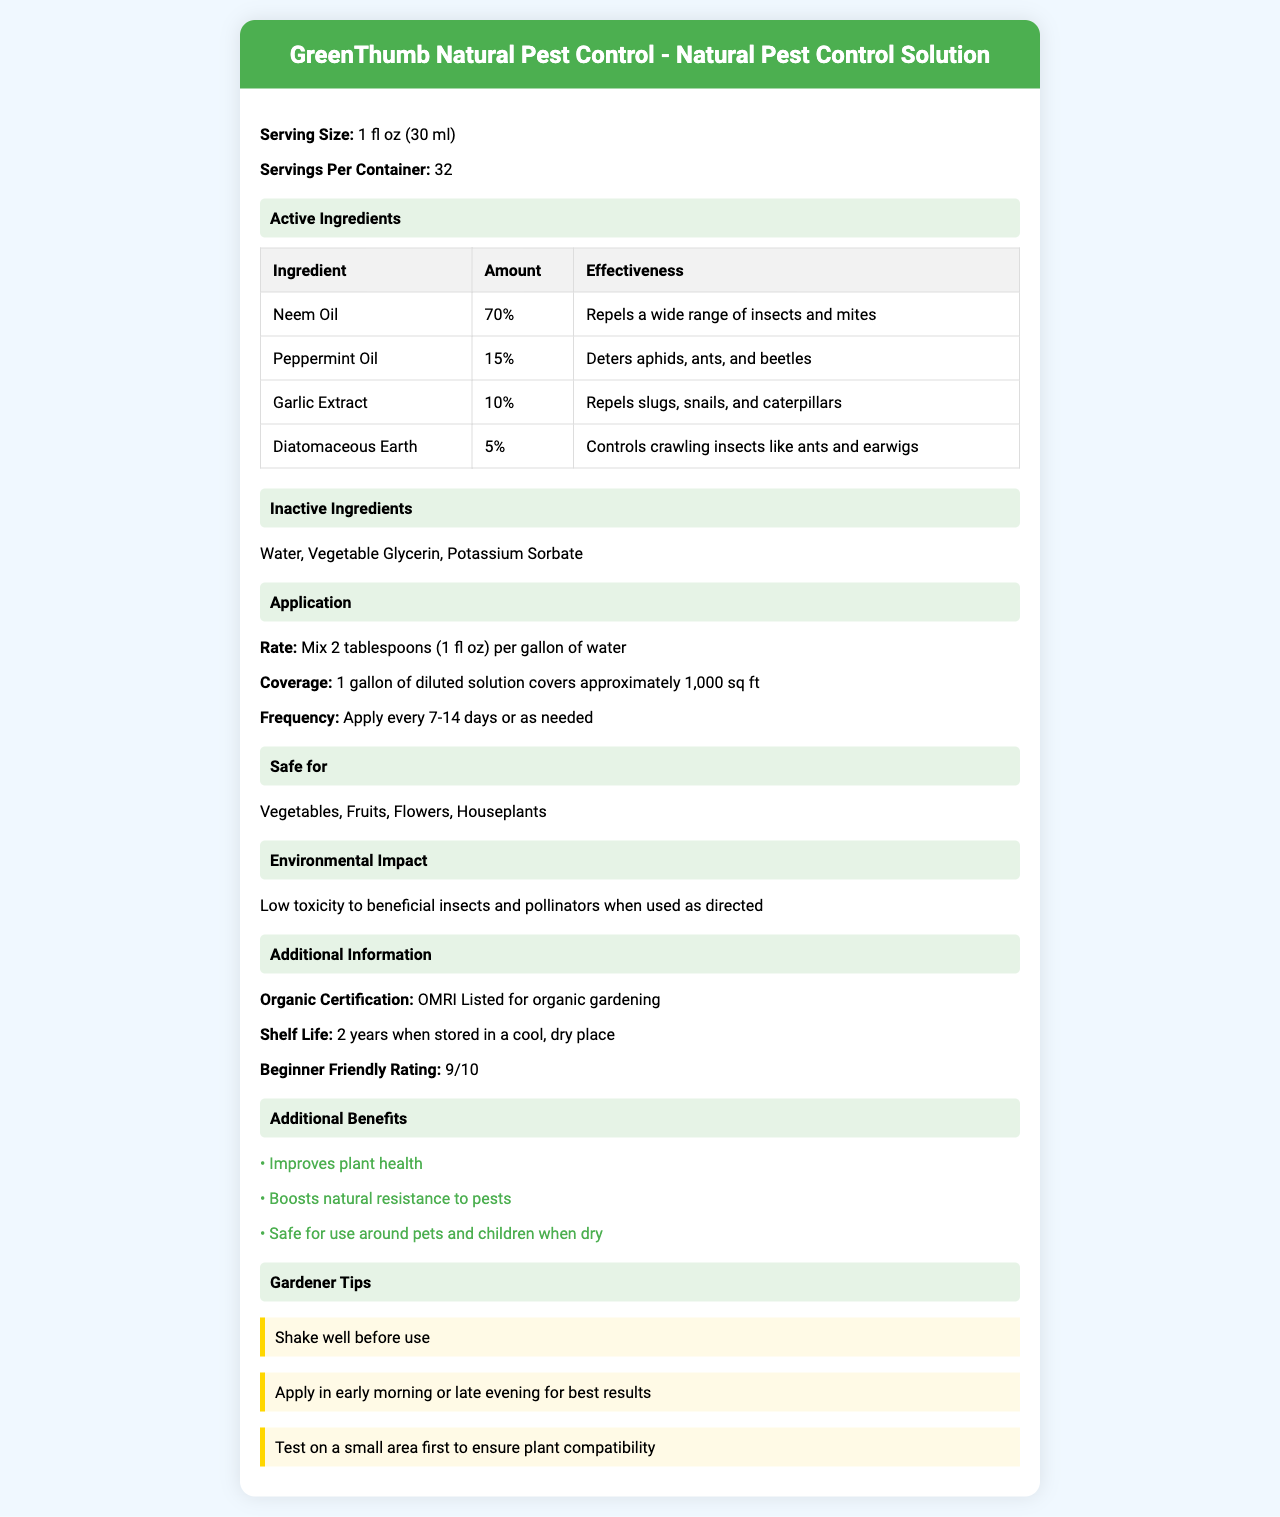what is the product name? The document specifies that the product name is "GreenThumb Natural Pest Control".
Answer: GreenThumb Natural Pest Control what is the serving size for the product? The serving size is mentioned as 1 fl oz (30 ml).
Answer: 1 fl oz (30 ml) how many servings per container are there? The document states that there are 32 servings per container.
Answer: 32 what percentage of the product is neem oil? Neem oil is listed as making up 70% of the product's active ingredients.
Answer: 70% what insects does peppermint oil deter? According to the document, peppermint oil deters aphids, ants, and beetles.
Answer: Aphids, ants, and beetles what is the application rate for the product? The application rate is specified as mixing 2 tablespoons (1 fl oz) per gallon of water.
Answer: Mix 2 tablespoons (1 fl oz) per gallon of water how often should the product be applied? The frequency of use is mentioned as applying every 7-14 days or as needed.
Answer: Every 7-14 days or as needed what is the organic certification of the product? The product is OMRI Listed for organic gardening.
Answer: OMRI Listed for organic gardening what is the shelf life of the product? The shelf life is specified as 2 years when stored in a cool, dry place.
Answer: 2 years when stored in a cool, dry place what is the beginner friendly rating of the product? The beginner friendly rating is given as 9/10.
Answer: 9/10 which of the following is NOT an active ingredient in the product? A. Neem Oil B. Peppermint Oil C. Water D. Garlic Extract Water is listed as an inactive ingredient, not an active one.
Answer: C what type of insects does garlic extract repel? A. Beetles B. Slugs C. Bees D. Mites Garlic extract repels slugs, snails, and caterpillars.
Answer: B is the product safe for use around pets and children when dry? The document mentions that the product is safe for use around pets and children when dry.
Answer: Yes describe the main idea of the document The document covers various aspects of the product, such as its ingredients, safety, application rate, effectiveness, and additional benefits. It is intended to help users understand how to use the product effectively and safely.
Answer: The document provides a detailed overview of GreenThumb Natural Pest Control, including its active and inactive ingredients, application instructions, safety information, and benefits. It also includes gardener tips for best results. what is the total volume of the product in a container? The document does not provide the total volume of the product in a container, although it mentions serving size and servings per container.
Answer: Not enough information 